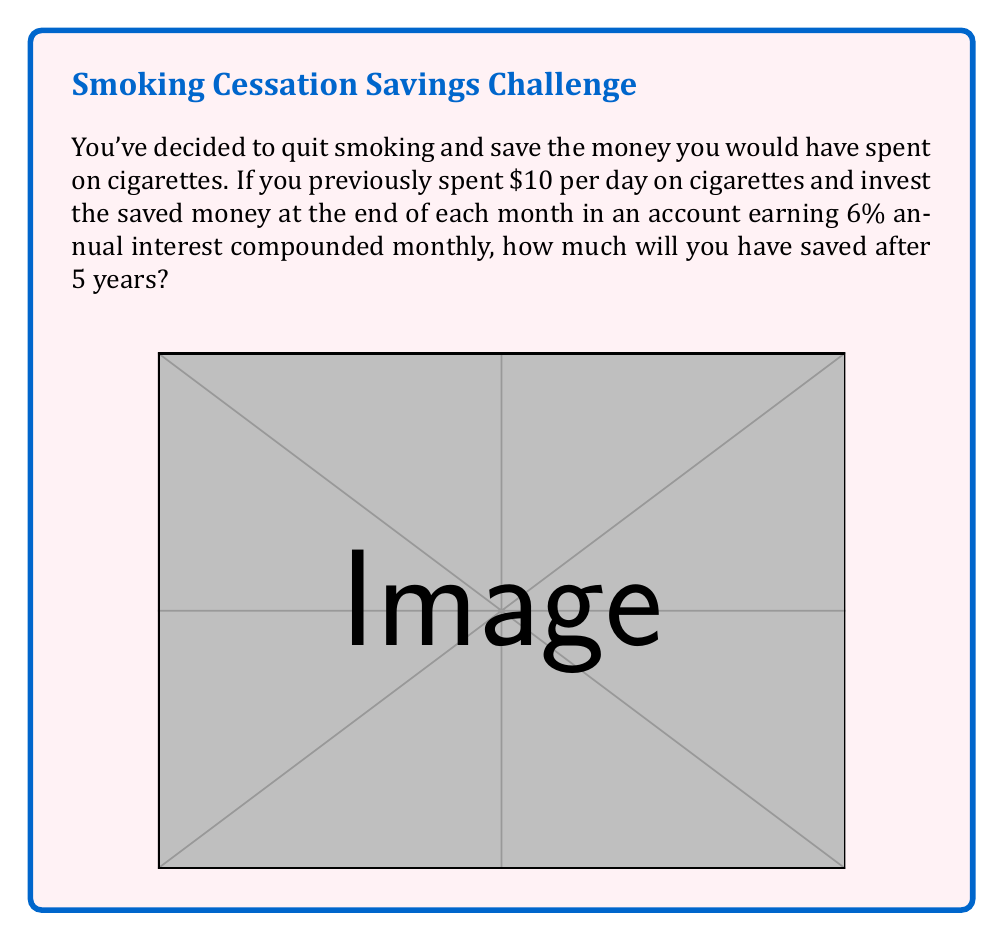Solve this math problem. Let's approach this step-by-step:

1) First, calculate the monthly savings:
   $10 per day × 30 days = $300 per month

2) We'll use the compound interest formula for regular contributions:
   $$A = P \frac{(1 + r/n)^{nt} - 1}{r/n}$$
   Where:
   A = final amount
   P = regular payment (monthly in this case)
   r = annual interest rate (as a decimal)
   n = number of times interest is compounded per year
   t = number of years

3) Plugging in our values:
   P = $300
   r = 0.06 (6% as a decimal)
   n = 12 (compounded monthly)
   t = 5 years

4) Now, let's substitute these into our formula:
   $$A = 300 \frac{(1 + 0.06/12)^{12(5)} - 1}{0.06/12}$$

5) Simplify:
   $$A = 300 \frac{(1.005)^{60} - 1}{0.005}$$

6) Use a calculator to evaluate:
   $$A = 300 \frac{1.3489514 - 1}{0.005} = 20,934.17$$

Therefore, after 5 years, you will have saved approximately $20,934.17.
Answer: $20,934.17 